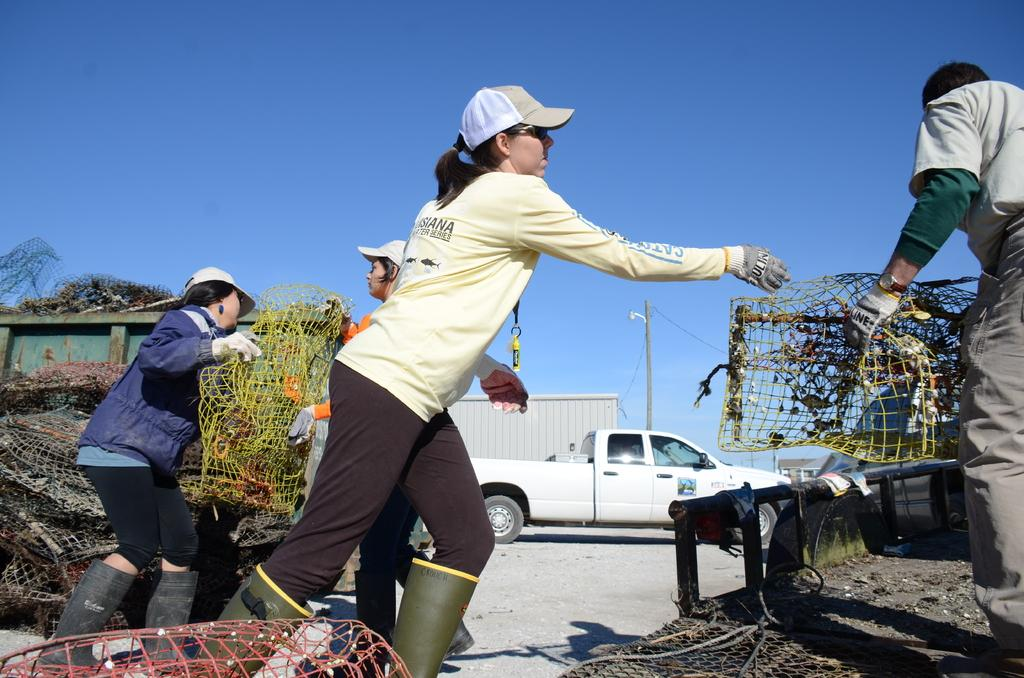What can be seen in the image? There are vehicles and people in the image. What are some people doing in the image? Some people are holding objects in the image. What is on the ground in the image? There are objects on the ground in the image. What can be seen in the background of the image? There is a pole and the sky visible in the background of the image. What type of cave can be seen in the image? There is no cave present in the image. Where is the vacation destination depicted in the image? The image does not depict a vacation destination; it shows vehicles, people, and objects. 